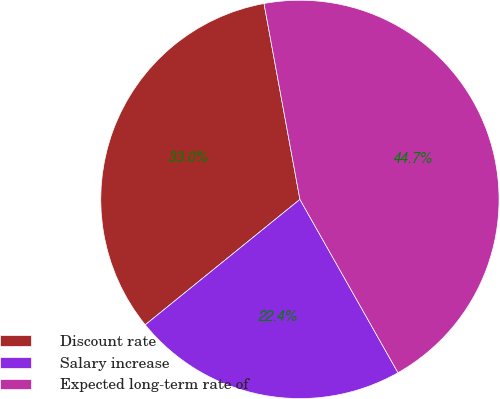<chart> <loc_0><loc_0><loc_500><loc_500><pie_chart><fcel>Discount rate<fcel>Salary increase<fcel>Expected long-term rate of<nl><fcel>32.96%<fcel>22.35%<fcel>44.69%<nl></chart> 